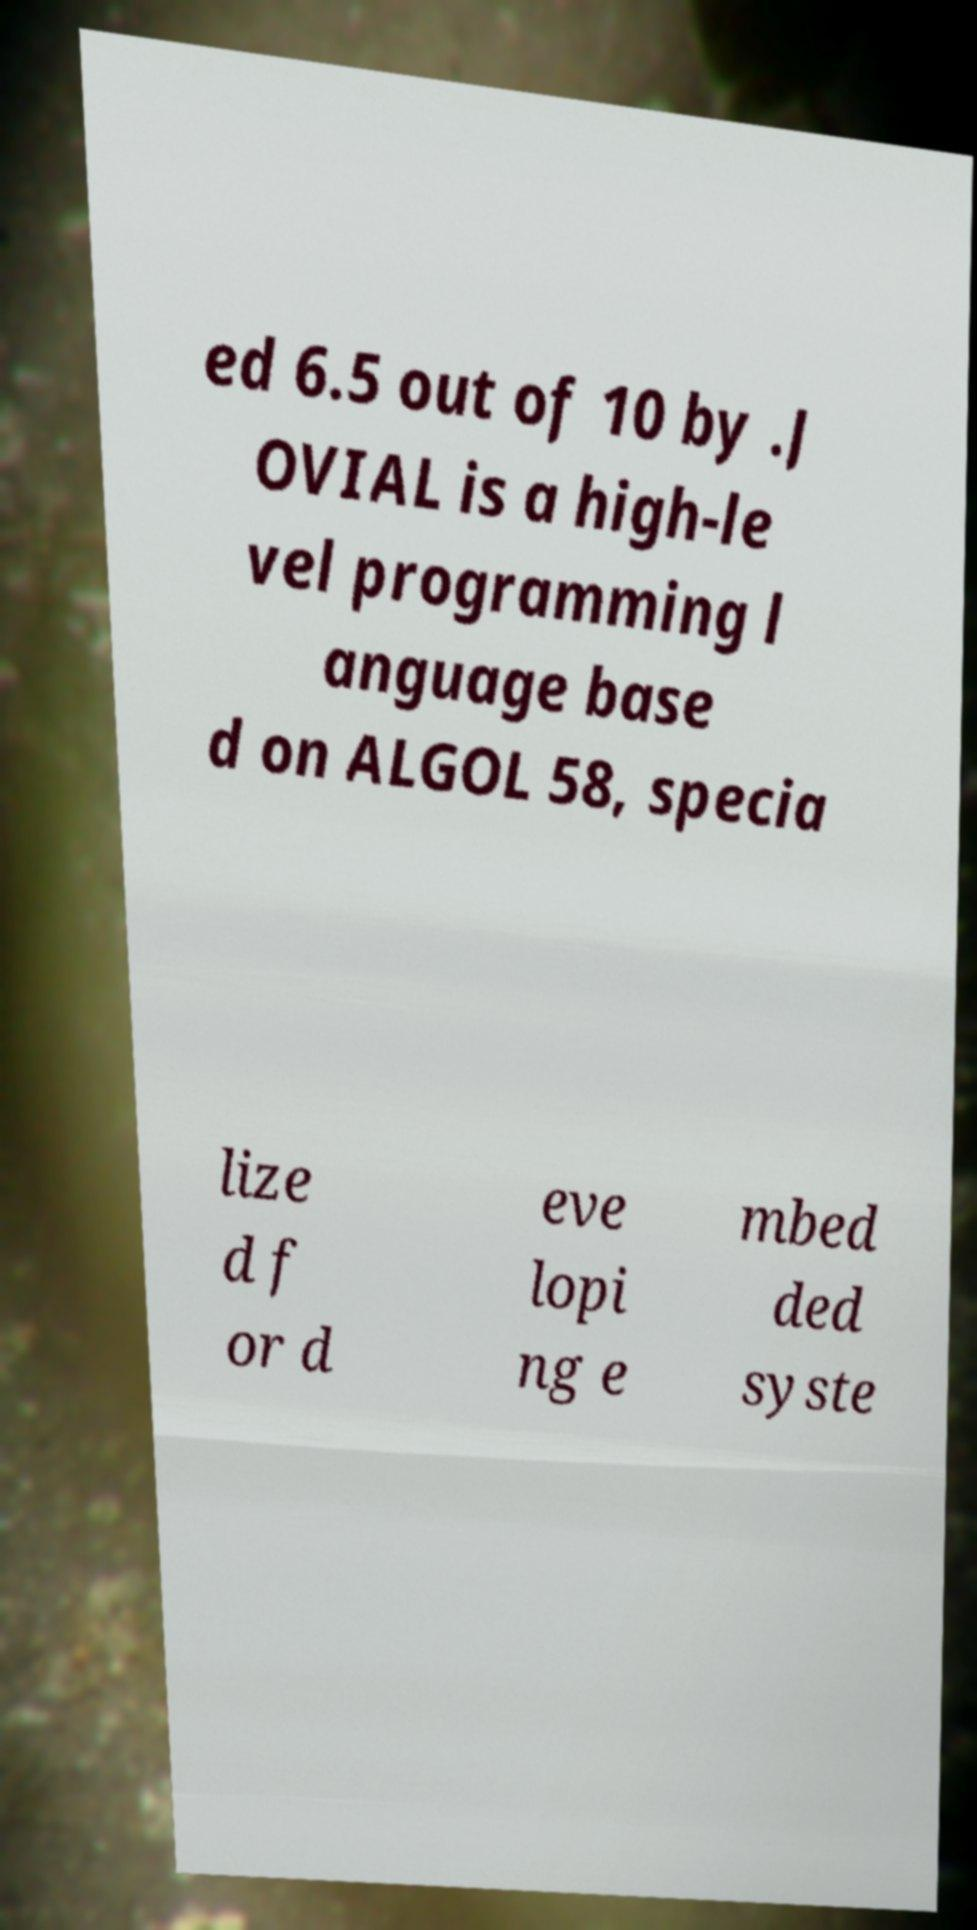I need the written content from this picture converted into text. Can you do that? ed 6.5 out of 10 by .J OVIAL is a high-le vel programming l anguage base d on ALGOL 58, specia lize d f or d eve lopi ng e mbed ded syste 